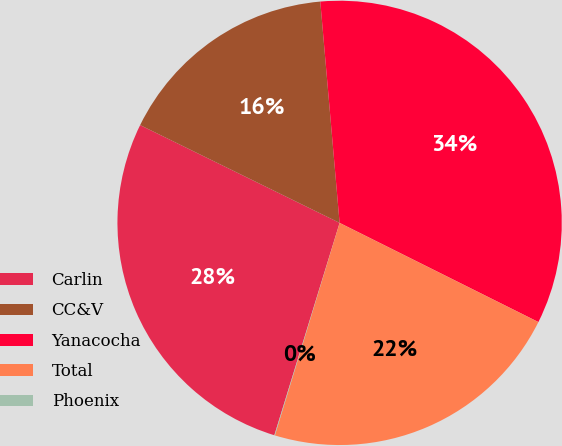Convert chart to OTSL. <chart><loc_0><loc_0><loc_500><loc_500><pie_chart><fcel>Carlin<fcel>CC&V<fcel>Yanacocha<fcel>Total<fcel>Phoenix<nl><fcel>27.51%<fcel>16.36%<fcel>33.75%<fcel>22.34%<fcel>0.04%<nl></chart> 